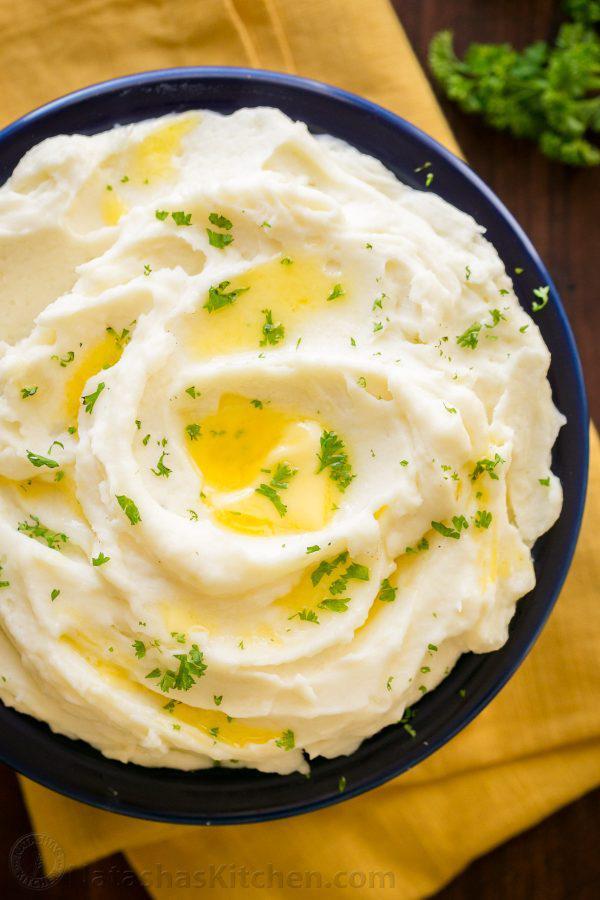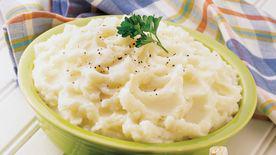The first image is the image on the left, the second image is the image on the right. Given the left and right images, does the statement "the mashed potato on the right image is on a white bowl." hold true? Answer yes or no. No. 